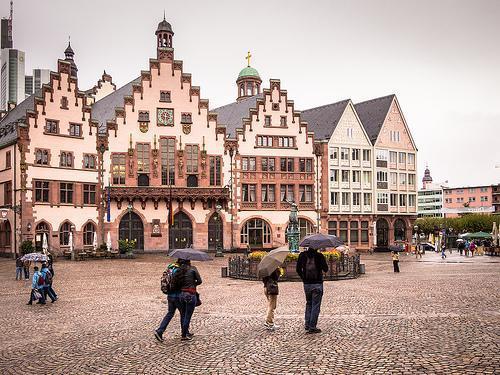How many fountains are there?
Give a very brief answer. 1. 